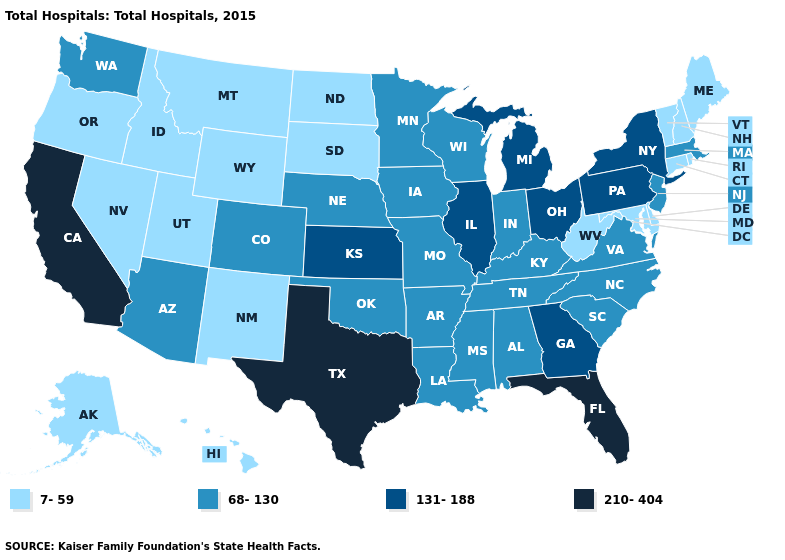Does Texas have the lowest value in the USA?
Write a very short answer. No. Does Iowa have the lowest value in the USA?
Keep it brief. No. Does Massachusetts have a lower value than Nebraska?
Write a very short answer. No. Does California have the highest value in the USA?
Give a very brief answer. Yes. What is the value of Arizona?
Give a very brief answer. 68-130. Does Connecticut have the same value as Nevada?
Keep it brief. Yes. Name the states that have a value in the range 131-188?
Answer briefly. Georgia, Illinois, Kansas, Michigan, New York, Ohio, Pennsylvania. Which states have the highest value in the USA?
Keep it brief. California, Florida, Texas. How many symbols are there in the legend?
Concise answer only. 4. What is the value of Arizona?
Give a very brief answer. 68-130. Does Utah have the highest value in the West?
Concise answer only. No. Which states have the lowest value in the Northeast?
Short answer required. Connecticut, Maine, New Hampshire, Rhode Island, Vermont. Does Utah have the same value as Mississippi?
Quick response, please. No. Which states have the lowest value in the USA?
Short answer required. Alaska, Connecticut, Delaware, Hawaii, Idaho, Maine, Maryland, Montana, Nevada, New Hampshire, New Mexico, North Dakota, Oregon, Rhode Island, South Dakota, Utah, Vermont, West Virginia, Wyoming. Does Maryland have the lowest value in the South?
Concise answer only. Yes. 